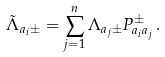Convert formula to latex. <formula><loc_0><loc_0><loc_500><loc_500>\tilde { \Lambda } _ { a _ { i } \pm } = \sum _ { j = 1 } ^ { n } \Lambda _ { a _ { j } \pm } P _ { a _ { i } a _ { j } } ^ { \pm } \, .</formula> 